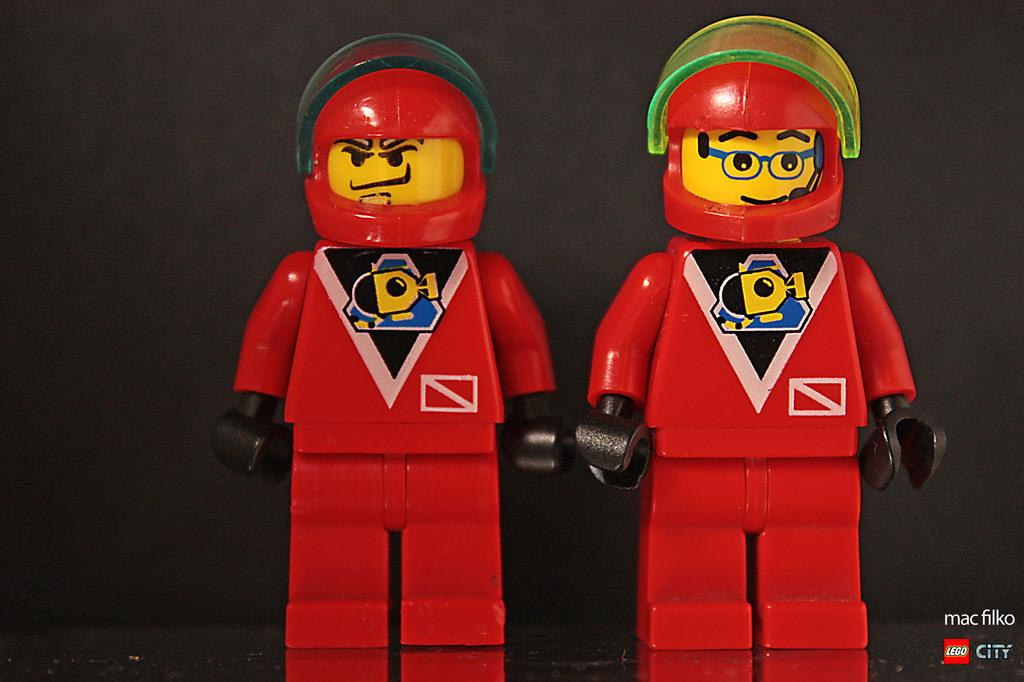How many dolls are in the image? There are two dolls in the image. What color are the dolls? The dolls are red in color. What part of the dolls is mentioned in the facts? The dolls' hands are mentioned in the facts. What color are the dolls' hands? The dolls' hands are black in color. What can be seen in the background of the image? There is a wall in the background of the image. What color is the wall? The wall is black in color. What type of silverware is being used by the dolls' uncle in the image? There is no mention of silverware or an uncle in the image, so it is not possible to answer that question. 